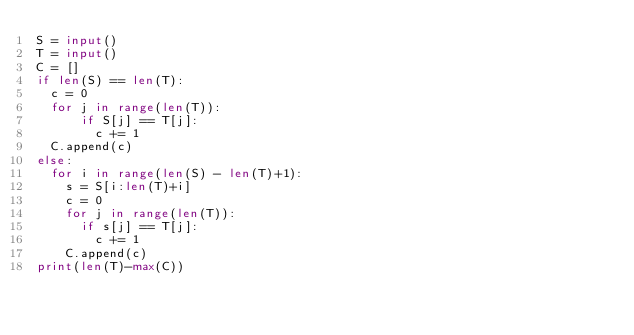Convert code to text. <code><loc_0><loc_0><loc_500><loc_500><_Python_>S = input()
T = input()
C = []
if len(S) == len(T):
  c = 0
  for j in range(len(T)):
      if S[j] == T[j]:
        c += 1
  C.append(c)
else:
  for i in range(len(S) - len(T)+1):
    s = S[i:len(T)+i]
    c = 0
    for j in range(len(T)):
      if s[j] == T[j]:
        c += 1
    C.append(c)
print(len(T)-max(C))</code> 